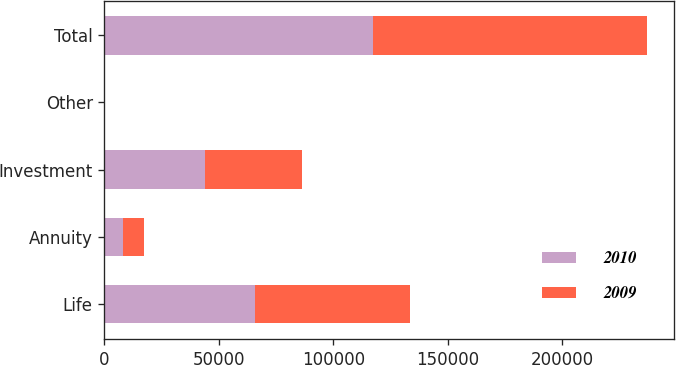Convert chart to OTSL. <chart><loc_0><loc_0><loc_500><loc_500><stacked_bar_chart><ecel><fcel>Life<fcel>Annuity<fcel>Investment<fcel>Other<fcel>Total<nl><fcel>2010<fcel>65726<fcel>7949<fcel>43787<fcel>103<fcel>117565<nl><fcel>2009<fcel>67917<fcel>9177<fcel>42375<fcel>22<fcel>119491<nl></chart> 